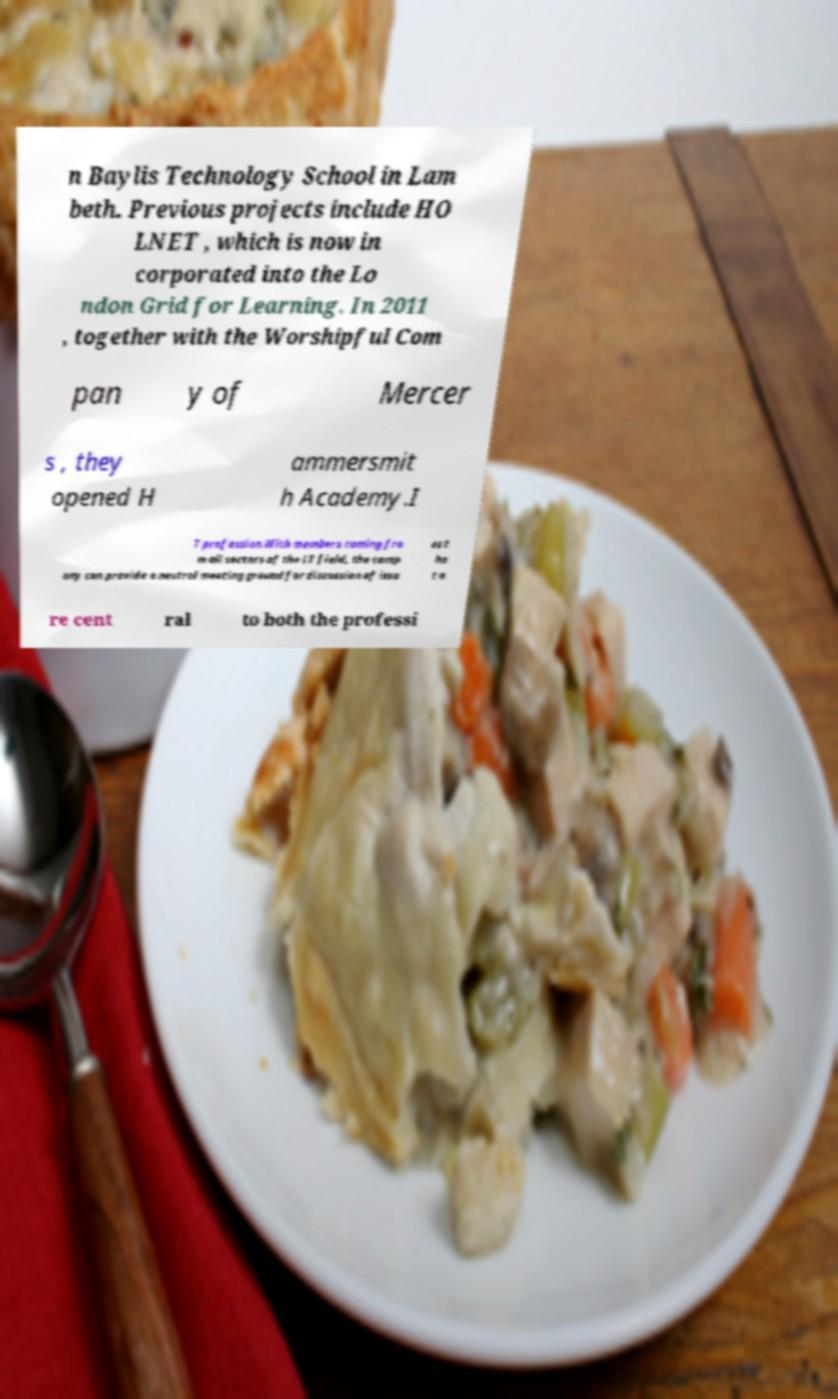What messages or text are displayed in this image? I need them in a readable, typed format. n Baylis Technology School in Lam beth. Previous projects include HO LNET , which is now in corporated into the Lo ndon Grid for Learning. In 2011 , together with the Worshipful Com pan y of Mercer s , they opened H ammersmit h Academy.I T profession.With members coming fro m all sectors of the IT field, the comp any can provide a neutral meeting ground for discussion of issu es t ha t a re cent ral to both the professi 